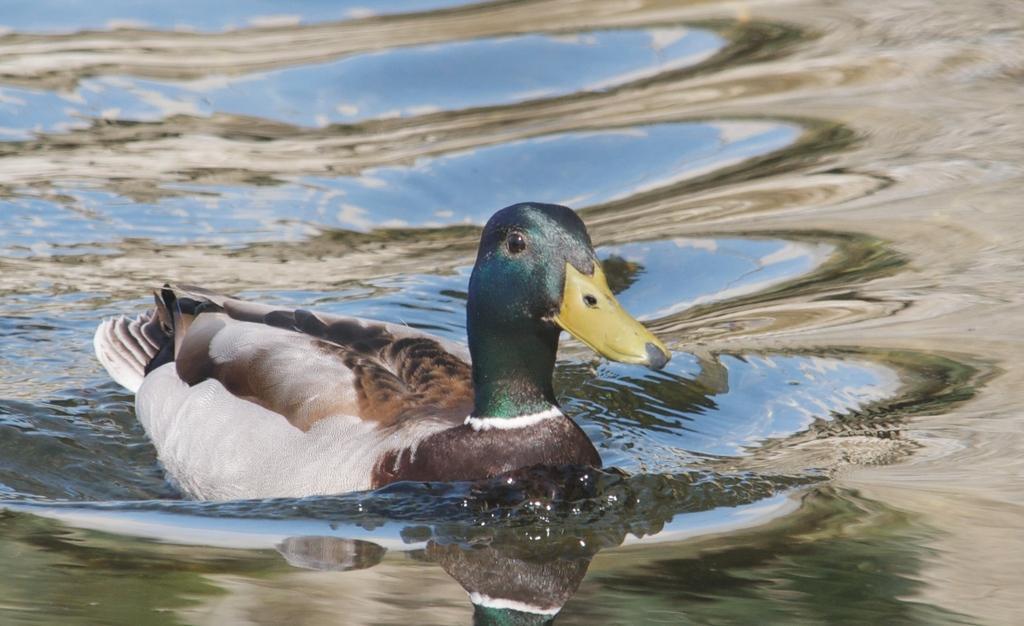In one or two sentences, can you explain what this image depicts? In the picture there is a duck swimming in the water. 